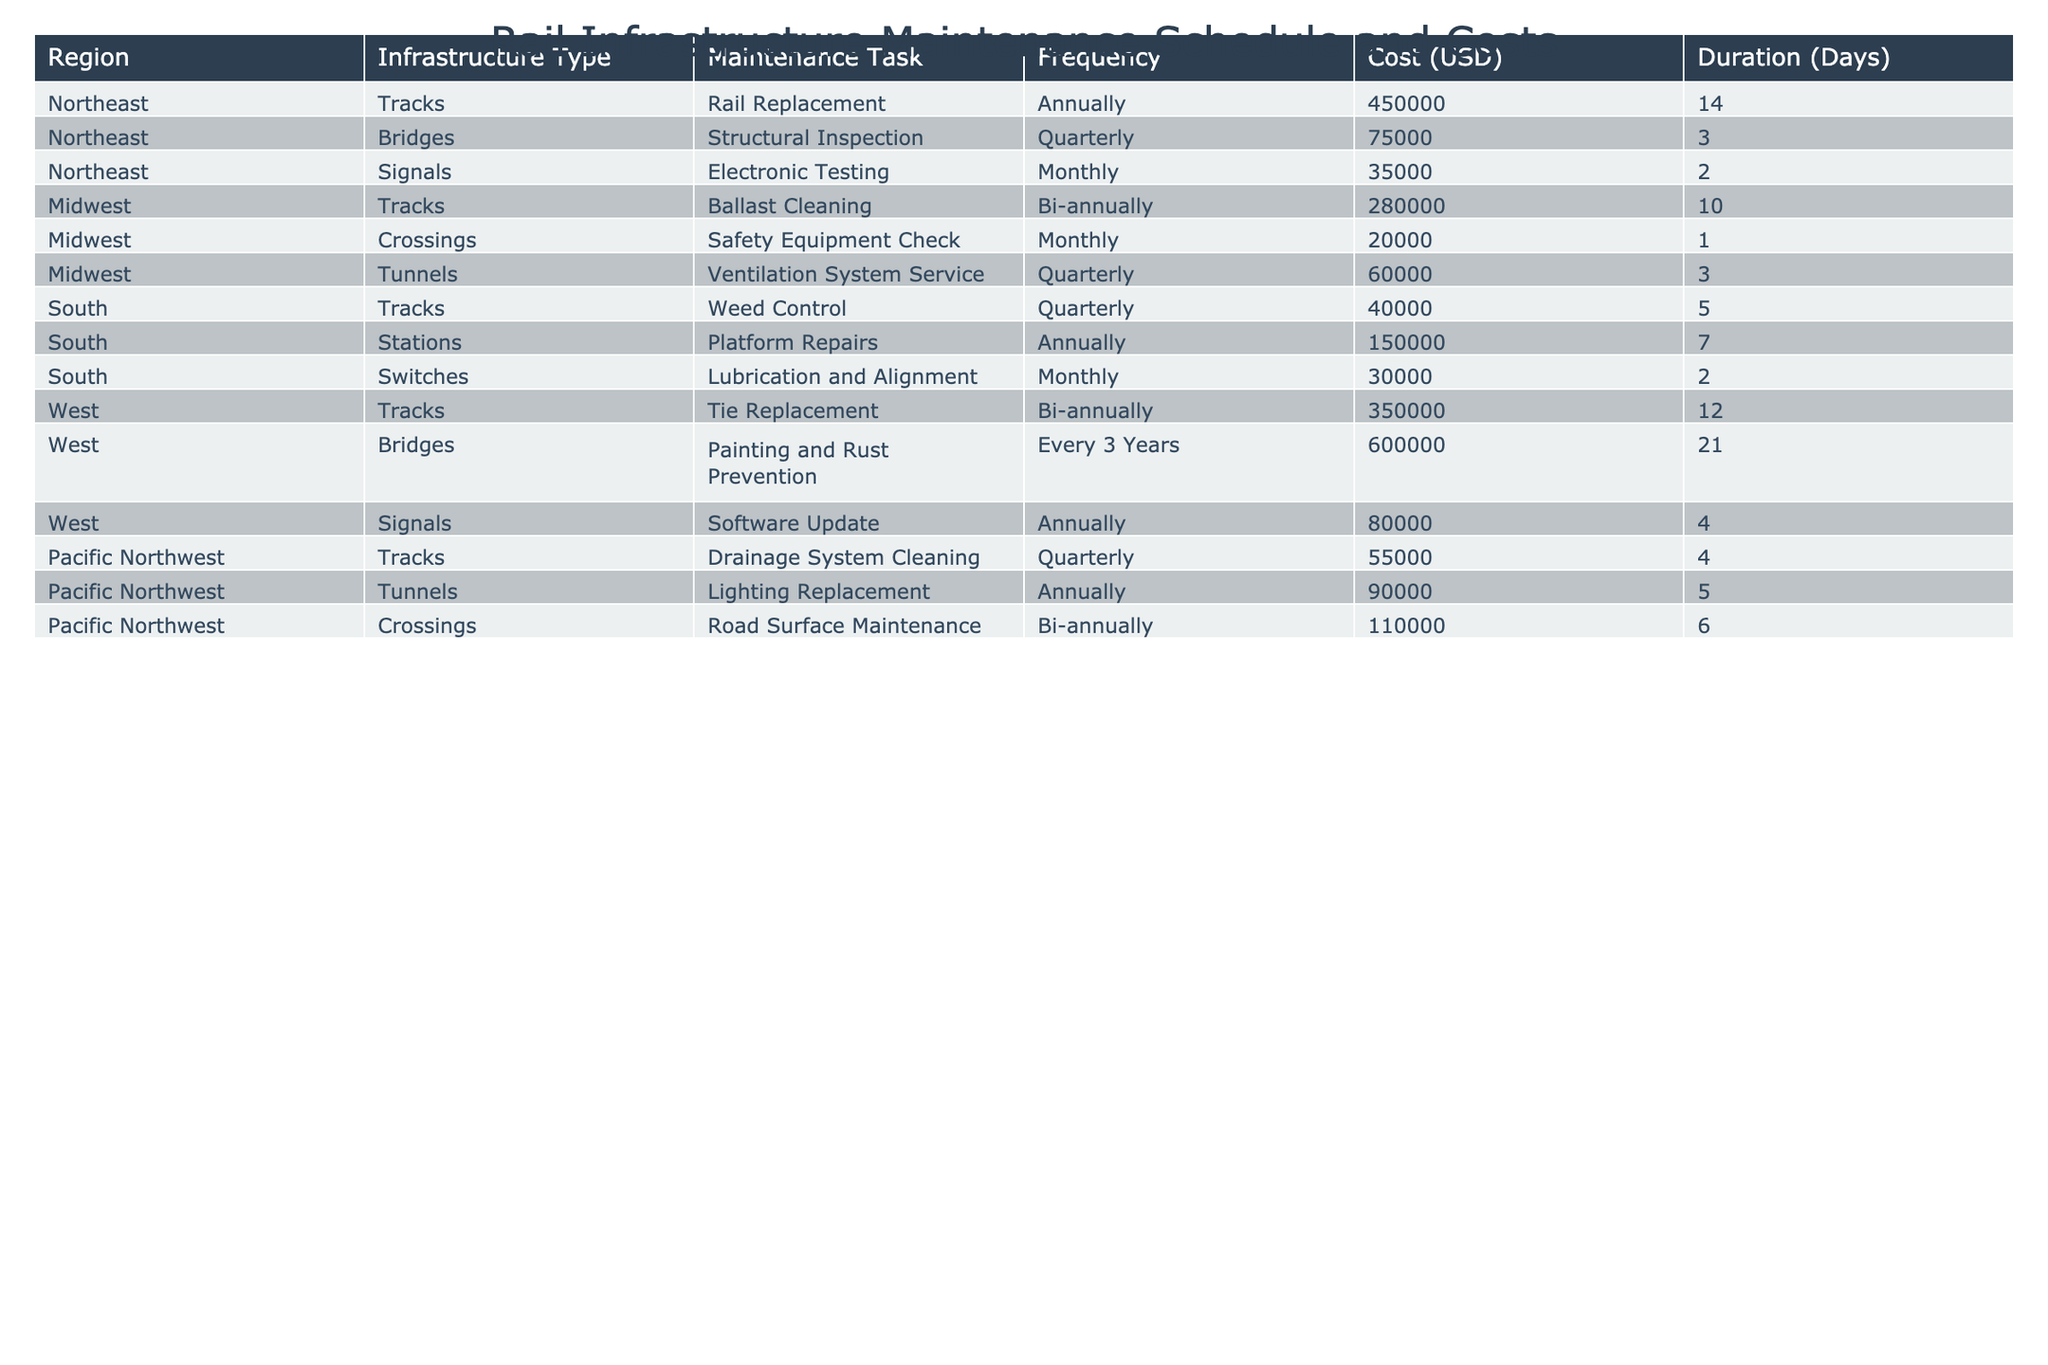What is the cost of the Rail Replacement task in the Northeast region? In the table, under the Northeast region, the maintenance task identified as Rail Replacement has a cost listed next to it. The cost is specified as 450000 USD.
Answer: 450000 Which maintenance task has the highest cost in the Midwest region? By reviewing the Midwest region's tasks, we see costs of 280000 USD for Ballast Cleaning, 20000 USD for Safety Equipment Check, and 60000 USD for Ventilation System Service. Among these, the highest cost is for Ballast Cleaning at 280000 USD.
Answer: 280000 How often is the Structural Inspection performed in the Northeast? In the Northeast section, next to the Structural Inspection task, the frequency is listed as Quarterly, indicating it is performed once every three months.
Answer: Quarterly What is the total maintenance cost for Track maintenance tasks across all regions? We need to isolate the costs associated with Track maintenance tasks from each region: Northeast (450000), Midwest (280000), South (40000), West (350000), and Pacific Northwest (55000). Adding these gives us a total of 450000 + 280000 + 40000 + 350000 + 55000 = 1175000 USD.
Answer: 1175000 Is there a maintenance task that occurs every 3 years in the West region? By checking the West region tasks, we find that the Painting and Rust Prevention task is listed with a frequency of "Every 3 Years." Therefore, there is indeed a task with that frequency in the West region.
Answer: Yes What is the average cost of maintenance tasks in the Pacific Northwest? The costs of the tasks in the Pacific Northwest are 55000, 90000, and 110000 USD. To find the average, we calculate the total: 55000 + 90000 + 110000 = 255000, and divide by the number of tasks (3), which yields an average of 85000 USD.
Answer: 85000 Which region has the longest duration for maintenance tasks? Analyzing the durations, we find the following maximum durations: Northeast (14 days), Midwest (10 days), South (7 days), West (21 days), and Pacific Northwest (6 days). The longest duration is 21 days for the West region.
Answer: West How many maintenance tasks are conducted monthly in the South region? In the South region, reviewing the tasks: Weed Control is Quarterly, Platform Repairs is Annual, and Lubrication and Alignment is Monthly. Only Lubrication and Alignment is performed monthly, adding up to 1 monthly task in the South.
Answer: 1 What maintenance task in the Midwest has the shortest duration? Among the tasks in the Midwest, we see that Safety Equipment Check has a duration of 1 day, Ballast Cleaning has 10 days, and Ventilation System Service has 3 days. The task with the shortest duration is Safety Equipment Check at 1 day.
Answer: Safety Equipment Check Which region has the highest total costs for maintenance tasks? First, we sum the total costs for each region: Northeast (450000 + 75000 + 35000 = 560000), Midwest (280000 + 20000 + 60000 = 360000), South (40000 + 150000 + 30000 = 220000), West (350000 + 600000 + 80000 = 1030000), and Pacific Northwest (55000 + 90000 + 110000 = 255000). The highest total is 1030000 for the West region.
Answer: West 